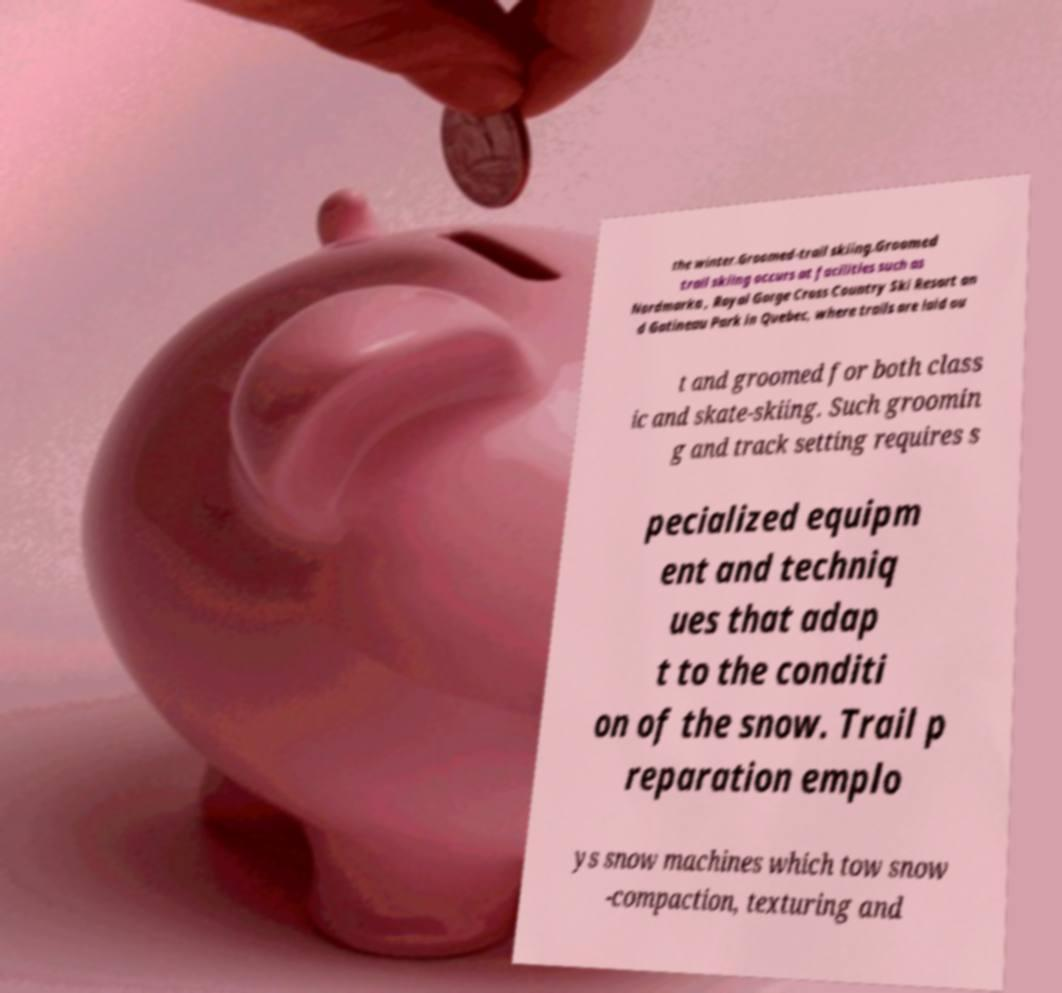There's text embedded in this image that I need extracted. Can you transcribe it verbatim? the winter.Groomed-trail skiing.Groomed trail skiing occurs at facilities such as Nordmarka , Royal Gorge Cross Country Ski Resort an d Gatineau Park in Quebec, where trails are laid ou t and groomed for both class ic and skate-skiing. Such groomin g and track setting requires s pecialized equipm ent and techniq ues that adap t to the conditi on of the snow. Trail p reparation emplo ys snow machines which tow snow -compaction, texturing and 